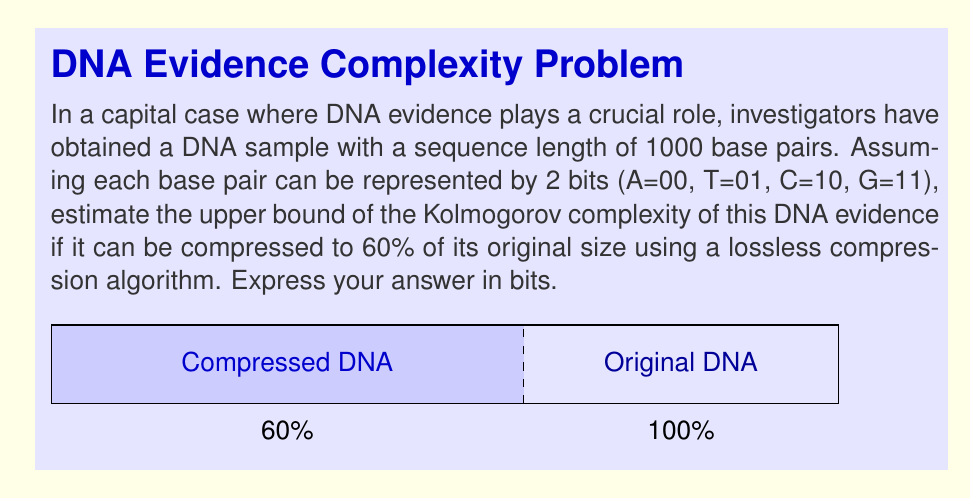Teach me how to tackle this problem. Let's approach this step-by-step:

1) First, calculate the original size of the DNA sequence in bits:
   $$1000 \text{ base pairs} \times 2 \text{ bits/base pair} = 2000 \text{ bits}$$

2) The sequence can be compressed to 60% of its original size. Calculate the compressed size:
   $$2000 \text{ bits} \times 0.60 = 1200 \text{ bits}$$

3) In information theory, the Kolmogorov complexity $K(x)$ of a string $x$ is the length of the shortest program that produces $x$ as its output. While it's generally not computable, we can estimate an upper bound.

4) The compressed size provides an upper bound for the Kolmogorov complexity. This is because the compression algorithm itself can be considered a program that generates the original string, and we know there can't be a shorter program than the optimal compression.

5) Therefore, the upper bound of the Kolmogorov complexity is at most the size of the compressed data, which is 1200 bits.

6) However, to be more precise, we should also account for the size of the decompression algorithm itself. Let's assume a simple decompression algorithm might require an additional 100 bits.

7) Thus, a tighter upper bound for the Kolmogorov complexity would be:
   $$1200 \text{ bits (compressed data)} + 100 \text{ bits (decompression algorithm)} = 1300 \text{ bits}$$

This estimate suggests that the DNA evidence can be described by a program of at most 1300 bits, which is significantly less than the original 2000 bits, indicating some level of structure or pattern in the DNA sequence.
Answer: 1300 bits 